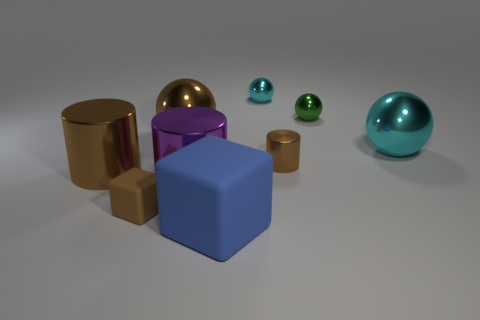Add 1 green metal balls. How many objects exist? 10 Subtract all spheres. How many objects are left? 5 Subtract 0 red cubes. How many objects are left? 9 Subtract all large purple metallic cylinders. Subtract all small cubes. How many objects are left? 7 Add 2 blue things. How many blue things are left? 3 Add 6 small shiny balls. How many small shiny balls exist? 8 